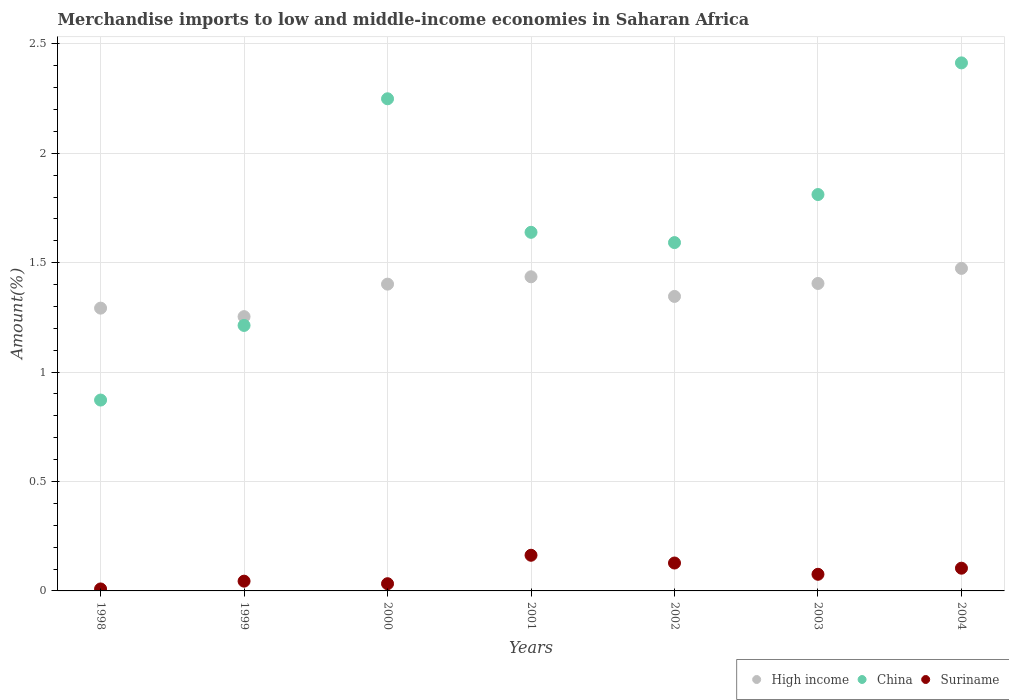Is the number of dotlines equal to the number of legend labels?
Your response must be concise. Yes. What is the percentage of amount earned from merchandise imports in Suriname in 2002?
Provide a succinct answer. 0.13. Across all years, what is the maximum percentage of amount earned from merchandise imports in Suriname?
Offer a very short reply. 0.16. Across all years, what is the minimum percentage of amount earned from merchandise imports in High income?
Provide a short and direct response. 1.25. What is the total percentage of amount earned from merchandise imports in Suriname in the graph?
Keep it short and to the point. 0.56. What is the difference between the percentage of amount earned from merchandise imports in China in 1999 and that in 2003?
Your response must be concise. -0.6. What is the difference between the percentage of amount earned from merchandise imports in High income in 2002 and the percentage of amount earned from merchandise imports in Suriname in 2000?
Make the answer very short. 1.31. What is the average percentage of amount earned from merchandise imports in Suriname per year?
Offer a terse response. 0.08. In the year 2004, what is the difference between the percentage of amount earned from merchandise imports in China and percentage of amount earned from merchandise imports in Suriname?
Offer a terse response. 2.31. What is the ratio of the percentage of amount earned from merchandise imports in Suriname in 2001 to that in 2003?
Keep it short and to the point. 2.14. Is the percentage of amount earned from merchandise imports in High income in 2001 less than that in 2003?
Your response must be concise. No. Is the difference between the percentage of amount earned from merchandise imports in China in 2000 and 2002 greater than the difference between the percentage of amount earned from merchandise imports in Suriname in 2000 and 2002?
Offer a terse response. Yes. What is the difference between the highest and the second highest percentage of amount earned from merchandise imports in High income?
Make the answer very short. 0.04. What is the difference between the highest and the lowest percentage of amount earned from merchandise imports in High income?
Ensure brevity in your answer.  0.22. In how many years, is the percentage of amount earned from merchandise imports in High income greater than the average percentage of amount earned from merchandise imports in High income taken over all years?
Offer a very short reply. 4. Is it the case that in every year, the sum of the percentage of amount earned from merchandise imports in China and percentage of amount earned from merchandise imports in High income  is greater than the percentage of amount earned from merchandise imports in Suriname?
Offer a terse response. Yes. Does the percentage of amount earned from merchandise imports in Suriname monotonically increase over the years?
Offer a very short reply. No. Is the percentage of amount earned from merchandise imports in China strictly less than the percentage of amount earned from merchandise imports in High income over the years?
Make the answer very short. No. How many dotlines are there?
Your response must be concise. 3. How many years are there in the graph?
Provide a short and direct response. 7. What is the difference between two consecutive major ticks on the Y-axis?
Your answer should be very brief. 0.5. Does the graph contain grids?
Provide a short and direct response. Yes. What is the title of the graph?
Offer a very short reply. Merchandise imports to low and middle-income economies in Saharan Africa. Does "Pacific island small states" appear as one of the legend labels in the graph?
Your answer should be very brief. No. What is the label or title of the Y-axis?
Give a very brief answer. Amount(%). What is the Amount(%) of High income in 1998?
Offer a very short reply. 1.29. What is the Amount(%) of China in 1998?
Your answer should be compact. 0.87. What is the Amount(%) in Suriname in 1998?
Provide a short and direct response. 0.01. What is the Amount(%) of High income in 1999?
Offer a very short reply. 1.25. What is the Amount(%) in China in 1999?
Make the answer very short. 1.21. What is the Amount(%) in Suriname in 1999?
Your answer should be very brief. 0.04. What is the Amount(%) of High income in 2000?
Your answer should be compact. 1.4. What is the Amount(%) of China in 2000?
Ensure brevity in your answer.  2.25. What is the Amount(%) in Suriname in 2000?
Offer a very short reply. 0.03. What is the Amount(%) in High income in 2001?
Provide a succinct answer. 1.44. What is the Amount(%) of China in 2001?
Ensure brevity in your answer.  1.64. What is the Amount(%) of Suriname in 2001?
Keep it short and to the point. 0.16. What is the Amount(%) in High income in 2002?
Offer a terse response. 1.35. What is the Amount(%) in China in 2002?
Your response must be concise. 1.59. What is the Amount(%) in Suriname in 2002?
Make the answer very short. 0.13. What is the Amount(%) in High income in 2003?
Provide a short and direct response. 1.41. What is the Amount(%) in China in 2003?
Provide a succinct answer. 1.81. What is the Amount(%) in Suriname in 2003?
Your response must be concise. 0.08. What is the Amount(%) in High income in 2004?
Give a very brief answer. 1.47. What is the Amount(%) of China in 2004?
Provide a short and direct response. 2.41. What is the Amount(%) of Suriname in 2004?
Offer a very short reply. 0.1. Across all years, what is the maximum Amount(%) in High income?
Make the answer very short. 1.47. Across all years, what is the maximum Amount(%) in China?
Provide a short and direct response. 2.41. Across all years, what is the maximum Amount(%) of Suriname?
Provide a short and direct response. 0.16. Across all years, what is the minimum Amount(%) in High income?
Provide a succinct answer. 1.25. Across all years, what is the minimum Amount(%) in China?
Your answer should be very brief. 0.87. Across all years, what is the minimum Amount(%) in Suriname?
Ensure brevity in your answer.  0.01. What is the total Amount(%) in High income in the graph?
Keep it short and to the point. 9.61. What is the total Amount(%) of China in the graph?
Your answer should be compact. 11.79. What is the total Amount(%) in Suriname in the graph?
Offer a terse response. 0.56. What is the difference between the Amount(%) in High income in 1998 and that in 1999?
Make the answer very short. 0.04. What is the difference between the Amount(%) in China in 1998 and that in 1999?
Make the answer very short. -0.34. What is the difference between the Amount(%) of Suriname in 1998 and that in 1999?
Keep it short and to the point. -0.04. What is the difference between the Amount(%) in High income in 1998 and that in 2000?
Provide a short and direct response. -0.11. What is the difference between the Amount(%) in China in 1998 and that in 2000?
Offer a terse response. -1.38. What is the difference between the Amount(%) in Suriname in 1998 and that in 2000?
Give a very brief answer. -0.02. What is the difference between the Amount(%) in High income in 1998 and that in 2001?
Give a very brief answer. -0.14. What is the difference between the Amount(%) in China in 1998 and that in 2001?
Keep it short and to the point. -0.77. What is the difference between the Amount(%) of Suriname in 1998 and that in 2001?
Your answer should be very brief. -0.15. What is the difference between the Amount(%) in High income in 1998 and that in 2002?
Keep it short and to the point. -0.05. What is the difference between the Amount(%) of China in 1998 and that in 2002?
Make the answer very short. -0.72. What is the difference between the Amount(%) in Suriname in 1998 and that in 2002?
Keep it short and to the point. -0.12. What is the difference between the Amount(%) of High income in 1998 and that in 2003?
Offer a terse response. -0.11. What is the difference between the Amount(%) in China in 1998 and that in 2003?
Provide a short and direct response. -0.94. What is the difference between the Amount(%) in Suriname in 1998 and that in 2003?
Give a very brief answer. -0.07. What is the difference between the Amount(%) of High income in 1998 and that in 2004?
Your response must be concise. -0.18. What is the difference between the Amount(%) of China in 1998 and that in 2004?
Give a very brief answer. -1.54. What is the difference between the Amount(%) in Suriname in 1998 and that in 2004?
Keep it short and to the point. -0.09. What is the difference between the Amount(%) in High income in 1999 and that in 2000?
Offer a very short reply. -0.15. What is the difference between the Amount(%) of China in 1999 and that in 2000?
Ensure brevity in your answer.  -1.04. What is the difference between the Amount(%) of Suriname in 1999 and that in 2000?
Offer a very short reply. 0.01. What is the difference between the Amount(%) of High income in 1999 and that in 2001?
Keep it short and to the point. -0.18. What is the difference between the Amount(%) in China in 1999 and that in 2001?
Your answer should be very brief. -0.43. What is the difference between the Amount(%) of Suriname in 1999 and that in 2001?
Your response must be concise. -0.12. What is the difference between the Amount(%) of High income in 1999 and that in 2002?
Your answer should be compact. -0.09. What is the difference between the Amount(%) in China in 1999 and that in 2002?
Provide a succinct answer. -0.38. What is the difference between the Amount(%) in Suriname in 1999 and that in 2002?
Ensure brevity in your answer.  -0.08. What is the difference between the Amount(%) of High income in 1999 and that in 2003?
Your response must be concise. -0.15. What is the difference between the Amount(%) in China in 1999 and that in 2003?
Provide a short and direct response. -0.6. What is the difference between the Amount(%) in Suriname in 1999 and that in 2003?
Offer a very short reply. -0.03. What is the difference between the Amount(%) of High income in 1999 and that in 2004?
Offer a terse response. -0.22. What is the difference between the Amount(%) in China in 1999 and that in 2004?
Keep it short and to the point. -1.2. What is the difference between the Amount(%) in Suriname in 1999 and that in 2004?
Provide a succinct answer. -0.06. What is the difference between the Amount(%) of High income in 2000 and that in 2001?
Offer a very short reply. -0.03. What is the difference between the Amount(%) of China in 2000 and that in 2001?
Provide a succinct answer. 0.61. What is the difference between the Amount(%) of Suriname in 2000 and that in 2001?
Offer a very short reply. -0.13. What is the difference between the Amount(%) in High income in 2000 and that in 2002?
Keep it short and to the point. 0.06. What is the difference between the Amount(%) of China in 2000 and that in 2002?
Provide a succinct answer. 0.66. What is the difference between the Amount(%) in Suriname in 2000 and that in 2002?
Offer a terse response. -0.09. What is the difference between the Amount(%) of High income in 2000 and that in 2003?
Keep it short and to the point. -0. What is the difference between the Amount(%) of China in 2000 and that in 2003?
Make the answer very short. 0.44. What is the difference between the Amount(%) of Suriname in 2000 and that in 2003?
Offer a very short reply. -0.04. What is the difference between the Amount(%) of High income in 2000 and that in 2004?
Make the answer very short. -0.07. What is the difference between the Amount(%) of China in 2000 and that in 2004?
Provide a short and direct response. -0.16. What is the difference between the Amount(%) of Suriname in 2000 and that in 2004?
Your response must be concise. -0.07. What is the difference between the Amount(%) in High income in 2001 and that in 2002?
Your answer should be compact. 0.09. What is the difference between the Amount(%) in China in 2001 and that in 2002?
Provide a succinct answer. 0.05. What is the difference between the Amount(%) of Suriname in 2001 and that in 2002?
Keep it short and to the point. 0.04. What is the difference between the Amount(%) in High income in 2001 and that in 2003?
Keep it short and to the point. 0.03. What is the difference between the Amount(%) in China in 2001 and that in 2003?
Make the answer very short. -0.17. What is the difference between the Amount(%) in Suriname in 2001 and that in 2003?
Your response must be concise. 0.09. What is the difference between the Amount(%) in High income in 2001 and that in 2004?
Provide a succinct answer. -0.04. What is the difference between the Amount(%) of China in 2001 and that in 2004?
Your answer should be compact. -0.77. What is the difference between the Amount(%) of Suriname in 2001 and that in 2004?
Make the answer very short. 0.06. What is the difference between the Amount(%) in High income in 2002 and that in 2003?
Your answer should be very brief. -0.06. What is the difference between the Amount(%) of China in 2002 and that in 2003?
Your answer should be very brief. -0.22. What is the difference between the Amount(%) in Suriname in 2002 and that in 2003?
Your response must be concise. 0.05. What is the difference between the Amount(%) in High income in 2002 and that in 2004?
Provide a short and direct response. -0.13. What is the difference between the Amount(%) in China in 2002 and that in 2004?
Give a very brief answer. -0.82. What is the difference between the Amount(%) in Suriname in 2002 and that in 2004?
Provide a succinct answer. 0.02. What is the difference between the Amount(%) in High income in 2003 and that in 2004?
Provide a succinct answer. -0.07. What is the difference between the Amount(%) of China in 2003 and that in 2004?
Provide a succinct answer. -0.6. What is the difference between the Amount(%) of Suriname in 2003 and that in 2004?
Provide a short and direct response. -0.03. What is the difference between the Amount(%) in High income in 1998 and the Amount(%) in China in 1999?
Your response must be concise. 0.08. What is the difference between the Amount(%) in High income in 1998 and the Amount(%) in Suriname in 1999?
Offer a very short reply. 1.25. What is the difference between the Amount(%) in China in 1998 and the Amount(%) in Suriname in 1999?
Your answer should be compact. 0.83. What is the difference between the Amount(%) of High income in 1998 and the Amount(%) of China in 2000?
Keep it short and to the point. -0.96. What is the difference between the Amount(%) of High income in 1998 and the Amount(%) of Suriname in 2000?
Your answer should be compact. 1.26. What is the difference between the Amount(%) of China in 1998 and the Amount(%) of Suriname in 2000?
Give a very brief answer. 0.84. What is the difference between the Amount(%) in High income in 1998 and the Amount(%) in China in 2001?
Give a very brief answer. -0.35. What is the difference between the Amount(%) of High income in 1998 and the Amount(%) of Suriname in 2001?
Your response must be concise. 1.13. What is the difference between the Amount(%) in China in 1998 and the Amount(%) in Suriname in 2001?
Keep it short and to the point. 0.71. What is the difference between the Amount(%) in High income in 1998 and the Amount(%) in China in 2002?
Offer a terse response. -0.3. What is the difference between the Amount(%) of High income in 1998 and the Amount(%) of Suriname in 2002?
Offer a very short reply. 1.16. What is the difference between the Amount(%) in China in 1998 and the Amount(%) in Suriname in 2002?
Make the answer very short. 0.74. What is the difference between the Amount(%) in High income in 1998 and the Amount(%) in China in 2003?
Offer a very short reply. -0.52. What is the difference between the Amount(%) in High income in 1998 and the Amount(%) in Suriname in 2003?
Make the answer very short. 1.22. What is the difference between the Amount(%) in China in 1998 and the Amount(%) in Suriname in 2003?
Keep it short and to the point. 0.8. What is the difference between the Amount(%) in High income in 1998 and the Amount(%) in China in 2004?
Ensure brevity in your answer.  -1.12. What is the difference between the Amount(%) in High income in 1998 and the Amount(%) in Suriname in 2004?
Provide a short and direct response. 1.19. What is the difference between the Amount(%) in China in 1998 and the Amount(%) in Suriname in 2004?
Provide a succinct answer. 0.77. What is the difference between the Amount(%) of High income in 1999 and the Amount(%) of China in 2000?
Provide a succinct answer. -1. What is the difference between the Amount(%) in High income in 1999 and the Amount(%) in Suriname in 2000?
Ensure brevity in your answer.  1.22. What is the difference between the Amount(%) in China in 1999 and the Amount(%) in Suriname in 2000?
Provide a succinct answer. 1.18. What is the difference between the Amount(%) of High income in 1999 and the Amount(%) of China in 2001?
Keep it short and to the point. -0.39. What is the difference between the Amount(%) in High income in 1999 and the Amount(%) in Suriname in 2001?
Your answer should be compact. 1.09. What is the difference between the Amount(%) in China in 1999 and the Amount(%) in Suriname in 2001?
Make the answer very short. 1.05. What is the difference between the Amount(%) of High income in 1999 and the Amount(%) of China in 2002?
Your response must be concise. -0.34. What is the difference between the Amount(%) in High income in 1999 and the Amount(%) in Suriname in 2002?
Offer a very short reply. 1.13. What is the difference between the Amount(%) of China in 1999 and the Amount(%) of Suriname in 2002?
Give a very brief answer. 1.09. What is the difference between the Amount(%) of High income in 1999 and the Amount(%) of China in 2003?
Make the answer very short. -0.56. What is the difference between the Amount(%) of High income in 1999 and the Amount(%) of Suriname in 2003?
Provide a succinct answer. 1.18. What is the difference between the Amount(%) of China in 1999 and the Amount(%) of Suriname in 2003?
Give a very brief answer. 1.14. What is the difference between the Amount(%) of High income in 1999 and the Amount(%) of China in 2004?
Ensure brevity in your answer.  -1.16. What is the difference between the Amount(%) in High income in 1999 and the Amount(%) in Suriname in 2004?
Provide a short and direct response. 1.15. What is the difference between the Amount(%) of China in 1999 and the Amount(%) of Suriname in 2004?
Offer a very short reply. 1.11. What is the difference between the Amount(%) of High income in 2000 and the Amount(%) of China in 2001?
Your answer should be very brief. -0.24. What is the difference between the Amount(%) of High income in 2000 and the Amount(%) of Suriname in 2001?
Your response must be concise. 1.24. What is the difference between the Amount(%) of China in 2000 and the Amount(%) of Suriname in 2001?
Offer a terse response. 2.09. What is the difference between the Amount(%) of High income in 2000 and the Amount(%) of China in 2002?
Your answer should be compact. -0.19. What is the difference between the Amount(%) in High income in 2000 and the Amount(%) in Suriname in 2002?
Your answer should be compact. 1.27. What is the difference between the Amount(%) of China in 2000 and the Amount(%) of Suriname in 2002?
Your answer should be very brief. 2.12. What is the difference between the Amount(%) in High income in 2000 and the Amount(%) in China in 2003?
Your answer should be very brief. -0.41. What is the difference between the Amount(%) in High income in 2000 and the Amount(%) in Suriname in 2003?
Provide a succinct answer. 1.33. What is the difference between the Amount(%) in China in 2000 and the Amount(%) in Suriname in 2003?
Offer a very short reply. 2.17. What is the difference between the Amount(%) in High income in 2000 and the Amount(%) in China in 2004?
Ensure brevity in your answer.  -1.01. What is the difference between the Amount(%) in High income in 2000 and the Amount(%) in Suriname in 2004?
Your response must be concise. 1.3. What is the difference between the Amount(%) of China in 2000 and the Amount(%) of Suriname in 2004?
Offer a very short reply. 2.15. What is the difference between the Amount(%) of High income in 2001 and the Amount(%) of China in 2002?
Make the answer very short. -0.16. What is the difference between the Amount(%) of High income in 2001 and the Amount(%) of Suriname in 2002?
Make the answer very short. 1.31. What is the difference between the Amount(%) in China in 2001 and the Amount(%) in Suriname in 2002?
Give a very brief answer. 1.51. What is the difference between the Amount(%) of High income in 2001 and the Amount(%) of China in 2003?
Your answer should be very brief. -0.38. What is the difference between the Amount(%) of High income in 2001 and the Amount(%) of Suriname in 2003?
Provide a short and direct response. 1.36. What is the difference between the Amount(%) in China in 2001 and the Amount(%) in Suriname in 2003?
Make the answer very short. 1.56. What is the difference between the Amount(%) of High income in 2001 and the Amount(%) of China in 2004?
Give a very brief answer. -0.98. What is the difference between the Amount(%) of High income in 2001 and the Amount(%) of Suriname in 2004?
Make the answer very short. 1.33. What is the difference between the Amount(%) in China in 2001 and the Amount(%) in Suriname in 2004?
Provide a short and direct response. 1.53. What is the difference between the Amount(%) in High income in 2002 and the Amount(%) in China in 2003?
Offer a terse response. -0.47. What is the difference between the Amount(%) in High income in 2002 and the Amount(%) in Suriname in 2003?
Keep it short and to the point. 1.27. What is the difference between the Amount(%) of China in 2002 and the Amount(%) of Suriname in 2003?
Your answer should be very brief. 1.52. What is the difference between the Amount(%) of High income in 2002 and the Amount(%) of China in 2004?
Give a very brief answer. -1.07. What is the difference between the Amount(%) in High income in 2002 and the Amount(%) in Suriname in 2004?
Provide a succinct answer. 1.24. What is the difference between the Amount(%) in China in 2002 and the Amount(%) in Suriname in 2004?
Provide a short and direct response. 1.49. What is the difference between the Amount(%) in High income in 2003 and the Amount(%) in China in 2004?
Give a very brief answer. -1.01. What is the difference between the Amount(%) in High income in 2003 and the Amount(%) in Suriname in 2004?
Provide a succinct answer. 1.3. What is the difference between the Amount(%) of China in 2003 and the Amount(%) of Suriname in 2004?
Offer a terse response. 1.71. What is the average Amount(%) in High income per year?
Your answer should be very brief. 1.37. What is the average Amount(%) of China per year?
Your response must be concise. 1.68. What is the average Amount(%) of Suriname per year?
Give a very brief answer. 0.08. In the year 1998, what is the difference between the Amount(%) of High income and Amount(%) of China?
Your answer should be very brief. 0.42. In the year 1998, what is the difference between the Amount(%) in High income and Amount(%) in Suriname?
Provide a succinct answer. 1.28. In the year 1998, what is the difference between the Amount(%) in China and Amount(%) in Suriname?
Offer a terse response. 0.86. In the year 1999, what is the difference between the Amount(%) in High income and Amount(%) in China?
Offer a terse response. 0.04. In the year 1999, what is the difference between the Amount(%) in High income and Amount(%) in Suriname?
Ensure brevity in your answer.  1.21. In the year 1999, what is the difference between the Amount(%) in China and Amount(%) in Suriname?
Make the answer very short. 1.17. In the year 2000, what is the difference between the Amount(%) of High income and Amount(%) of China?
Your answer should be compact. -0.85. In the year 2000, what is the difference between the Amount(%) in High income and Amount(%) in Suriname?
Offer a terse response. 1.37. In the year 2000, what is the difference between the Amount(%) of China and Amount(%) of Suriname?
Give a very brief answer. 2.22. In the year 2001, what is the difference between the Amount(%) of High income and Amount(%) of China?
Provide a succinct answer. -0.2. In the year 2001, what is the difference between the Amount(%) in High income and Amount(%) in Suriname?
Offer a very short reply. 1.27. In the year 2001, what is the difference between the Amount(%) of China and Amount(%) of Suriname?
Offer a terse response. 1.48. In the year 2002, what is the difference between the Amount(%) of High income and Amount(%) of China?
Make the answer very short. -0.25. In the year 2002, what is the difference between the Amount(%) of High income and Amount(%) of Suriname?
Offer a very short reply. 1.22. In the year 2002, what is the difference between the Amount(%) in China and Amount(%) in Suriname?
Offer a terse response. 1.46. In the year 2003, what is the difference between the Amount(%) of High income and Amount(%) of China?
Offer a terse response. -0.41. In the year 2003, what is the difference between the Amount(%) in High income and Amount(%) in Suriname?
Offer a very short reply. 1.33. In the year 2003, what is the difference between the Amount(%) of China and Amount(%) of Suriname?
Your answer should be compact. 1.74. In the year 2004, what is the difference between the Amount(%) of High income and Amount(%) of China?
Provide a short and direct response. -0.94. In the year 2004, what is the difference between the Amount(%) in High income and Amount(%) in Suriname?
Give a very brief answer. 1.37. In the year 2004, what is the difference between the Amount(%) in China and Amount(%) in Suriname?
Give a very brief answer. 2.31. What is the ratio of the Amount(%) of High income in 1998 to that in 1999?
Offer a terse response. 1.03. What is the ratio of the Amount(%) in China in 1998 to that in 1999?
Ensure brevity in your answer.  0.72. What is the ratio of the Amount(%) of Suriname in 1998 to that in 1999?
Give a very brief answer. 0.2. What is the ratio of the Amount(%) in High income in 1998 to that in 2000?
Your answer should be compact. 0.92. What is the ratio of the Amount(%) of China in 1998 to that in 2000?
Offer a very short reply. 0.39. What is the ratio of the Amount(%) of Suriname in 1998 to that in 2000?
Provide a short and direct response. 0.28. What is the ratio of the Amount(%) in High income in 1998 to that in 2001?
Provide a short and direct response. 0.9. What is the ratio of the Amount(%) in China in 1998 to that in 2001?
Your response must be concise. 0.53. What is the ratio of the Amount(%) in Suriname in 1998 to that in 2001?
Your answer should be very brief. 0.06. What is the ratio of the Amount(%) of High income in 1998 to that in 2002?
Offer a very short reply. 0.96. What is the ratio of the Amount(%) in China in 1998 to that in 2002?
Your answer should be compact. 0.55. What is the ratio of the Amount(%) of Suriname in 1998 to that in 2002?
Offer a terse response. 0.07. What is the ratio of the Amount(%) in High income in 1998 to that in 2003?
Provide a short and direct response. 0.92. What is the ratio of the Amount(%) of China in 1998 to that in 2003?
Your answer should be compact. 0.48. What is the ratio of the Amount(%) in Suriname in 1998 to that in 2003?
Offer a terse response. 0.12. What is the ratio of the Amount(%) in High income in 1998 to that in 2004?
Your answer should be very brief. 0.88. What is the ratio of the Amount(%) of China in 1998 to that in 2004?
Give a very brief answer. 0.36. What is the ratio of the Amount(%) in Suriname in 1998 to that in 2004?
Your answer should be compact. 0.09. What is the ratio of the Amount(%) of High income in 1999 to that in 2000?
Give a very brief answer. 0.89. What is the ratio of the Amount(%) in China in 1999 to that in 2000?
Give a very brief answer. 0.54. What is the ratio of the Amount(%) in Suriname in 1999 to that in 2000?
Keep it short and to the point. 1.35. What is the ratio of the Amount(%) in High income in 1999 to that in 2001?
Give a very brief answer. 0.87. What is the ratio of the Amount(%) in China in 1999 to that in 2001?
Your answer should be compact. 0.74. What is the ratio of the Amount(%) in Suriname in 1999 to that in 2001?
Make the answer very short. 0.27. What is the ratio of the Amount(%) in High income in 1999 to that in 2002?
Keep it short and to the point. 0.93. What is the ratio of the Amount(%) of China in 1999 to that in 2002?
Make the answer very short. 0.76. What is the ratio of the Amount(%) in Suriname in 1999 to that in 2002?
Give a very brief answer. 0.35. What is the ratio of the Amount(%) in High income in 1999 to that in 2003?
Your answer should be compact. 0.89. What is the ratio of the Amount(%) of China in 1999 to that in 2003?
Provide a succinct answer. 0.67. What is the ratio of the Amount(%) in Suriname in 1999 to that in 2003?
Your answer should be very brief. 0.59. What is the ratio of the Amount(%) in High income in 1999 to that in 2004?
Keep it short and to the point. 0.85. What is the ratio of the Amount(%) in China in 1999 to that in 2004?
Offer a very short reply. 0.5. What is the ratio of the Amount(%) of Suriname in 1999 to that in 2004?
Offer a terse response. 0.43. What is the ratio of the Amount(%) in High income in 2000 to that in 2001?
Your response must be concise. 0.98. What is the ratio of the Amount(%) in China in 2000 to that in 2001?
Your response must be concise. 1.37. What is the ratio of the Amount(%) in Suriname in 2000 to that in 2001?
Your response must be concise. 0.2. What is the ratio of the Amount(%) in High income in 2000 to that in 2002?
Ensure brevity in your answer.  1.04. What is the ratio of the Amount(%) of China in 2000 to that in 2002?
Make the answer very short. 1.41. What is the ratio of the Amount(%) in Suriname in 2000 to that in 2002?
Your response must be concise. 0.26. What is the ratio of the Amount(%) in High income in 2000 to that in 2003?
Your response must be concise. 1. What is the ratio of the Amount(%) of China in 2000 to that in 2003?
Your response must be concise. 1.24. What is the ratio of the Amount(%) of Suriname in 2000 to that in 2003?
Your answer should be very brief. 0.43. What is the ratio of the Amount(%) of High income in 2000 to that in 2004?
Make the answer very short. 0.95. What is the ratio of the Amount(%) in China in 2000 to that in 2004?
Make the answer very short. 0.93. What is the ratio of the Amount(%) of Suriname in 2000 to that in 2004?
Keep it short and to the point. 0.32. What is the ratio of the Amount(%) of High income in 2001 to that in 2002?
Make the answer very short. 1.07. What is the ratio of the Amount(%) in China in 2001 to that in 2002?
Offer a very short reply. 1.03. What is the ratio of the Amount(%) of Suriname in 2001 to that in 2002?
Your response must be concise. 1.28. What is the ratio of the Amount(%) of High income in 2001 to that in 2003?
Offer a very short reply. 1.02. What is the ratio of the Amount(%) of China in 2001 to that in 2003?
Offer a very short reply. 0.9. What is the ratio of the Amount(%) in Suriname in 2001 to that in 2003?
Offer a terse response. 2.14. What is the ratio of the Amount(%) of High income in 2001 to that in 2004?
Your answer should be very brief. 0.97. What is the ratio of the Amount(%) of China in 2001 to that in 2004?
Make the answer very short. 0.68. What is the ratio of the Amount(%) in Suriname in 2001 to that in 2004?
Your answer should be compact. 1.57. What is the ratio of the Amount(%) in High income in 2002 to that in 2003?
Ensure brevity in your answer.  0.96. What is the ratio of the Amount(%) of China in 2002 to that in 2003?
Offer a very short reply. 0.88. What is the ratio of the Amount(%) of Suriname in 2002 to that in 2003?
Your answer should be very brief. 1.68. What is the ratio of the Amount(%) of High income in 2002 to that in 2004?
Give a very brief answer. 0.91. What is the ratio of the Amount(%) in China in 2002 to that in 2004?
Ensure brevity in your answer.  0.66. What is the ratio of the Amount(%) in Suriname in 2002 to that in 2004?
Make the answer very short. 1.23. What is the ratio of the Amount(%) in High income in 2003 to that in 2004?
Offer a terse response. 0.95. What is the ratio of the Amount(%) in China in 2003 to that in 2004?
Provide a succinct answer. 0.75. What is the ratio of the Amount(%) in Suriname in 2003 to that in 2004?
Give a very brief answer. 0.73. What is the difference between the highest and the second highest Amount(%) in High income?
Make the answer very short. 0.04. What is the difference between the highest and the second highest Amount(%) in China?
Offer a terse response. 0.16. What is the difference between the highest and the second highest Amount(%) of Suriname?
Give a very brief answer. 0.04. What is the difference between the highest and the lowest Amount(%) in High income?
Your answer should be very brief. 0.22. What is the difference between the highest and the lowest Amount(%) in China?
Your answer should be compact. 1.54. What is the difference between the highest and the lowest Amount(%) of Suriname?
Keep it short and to the point. 0.15. 